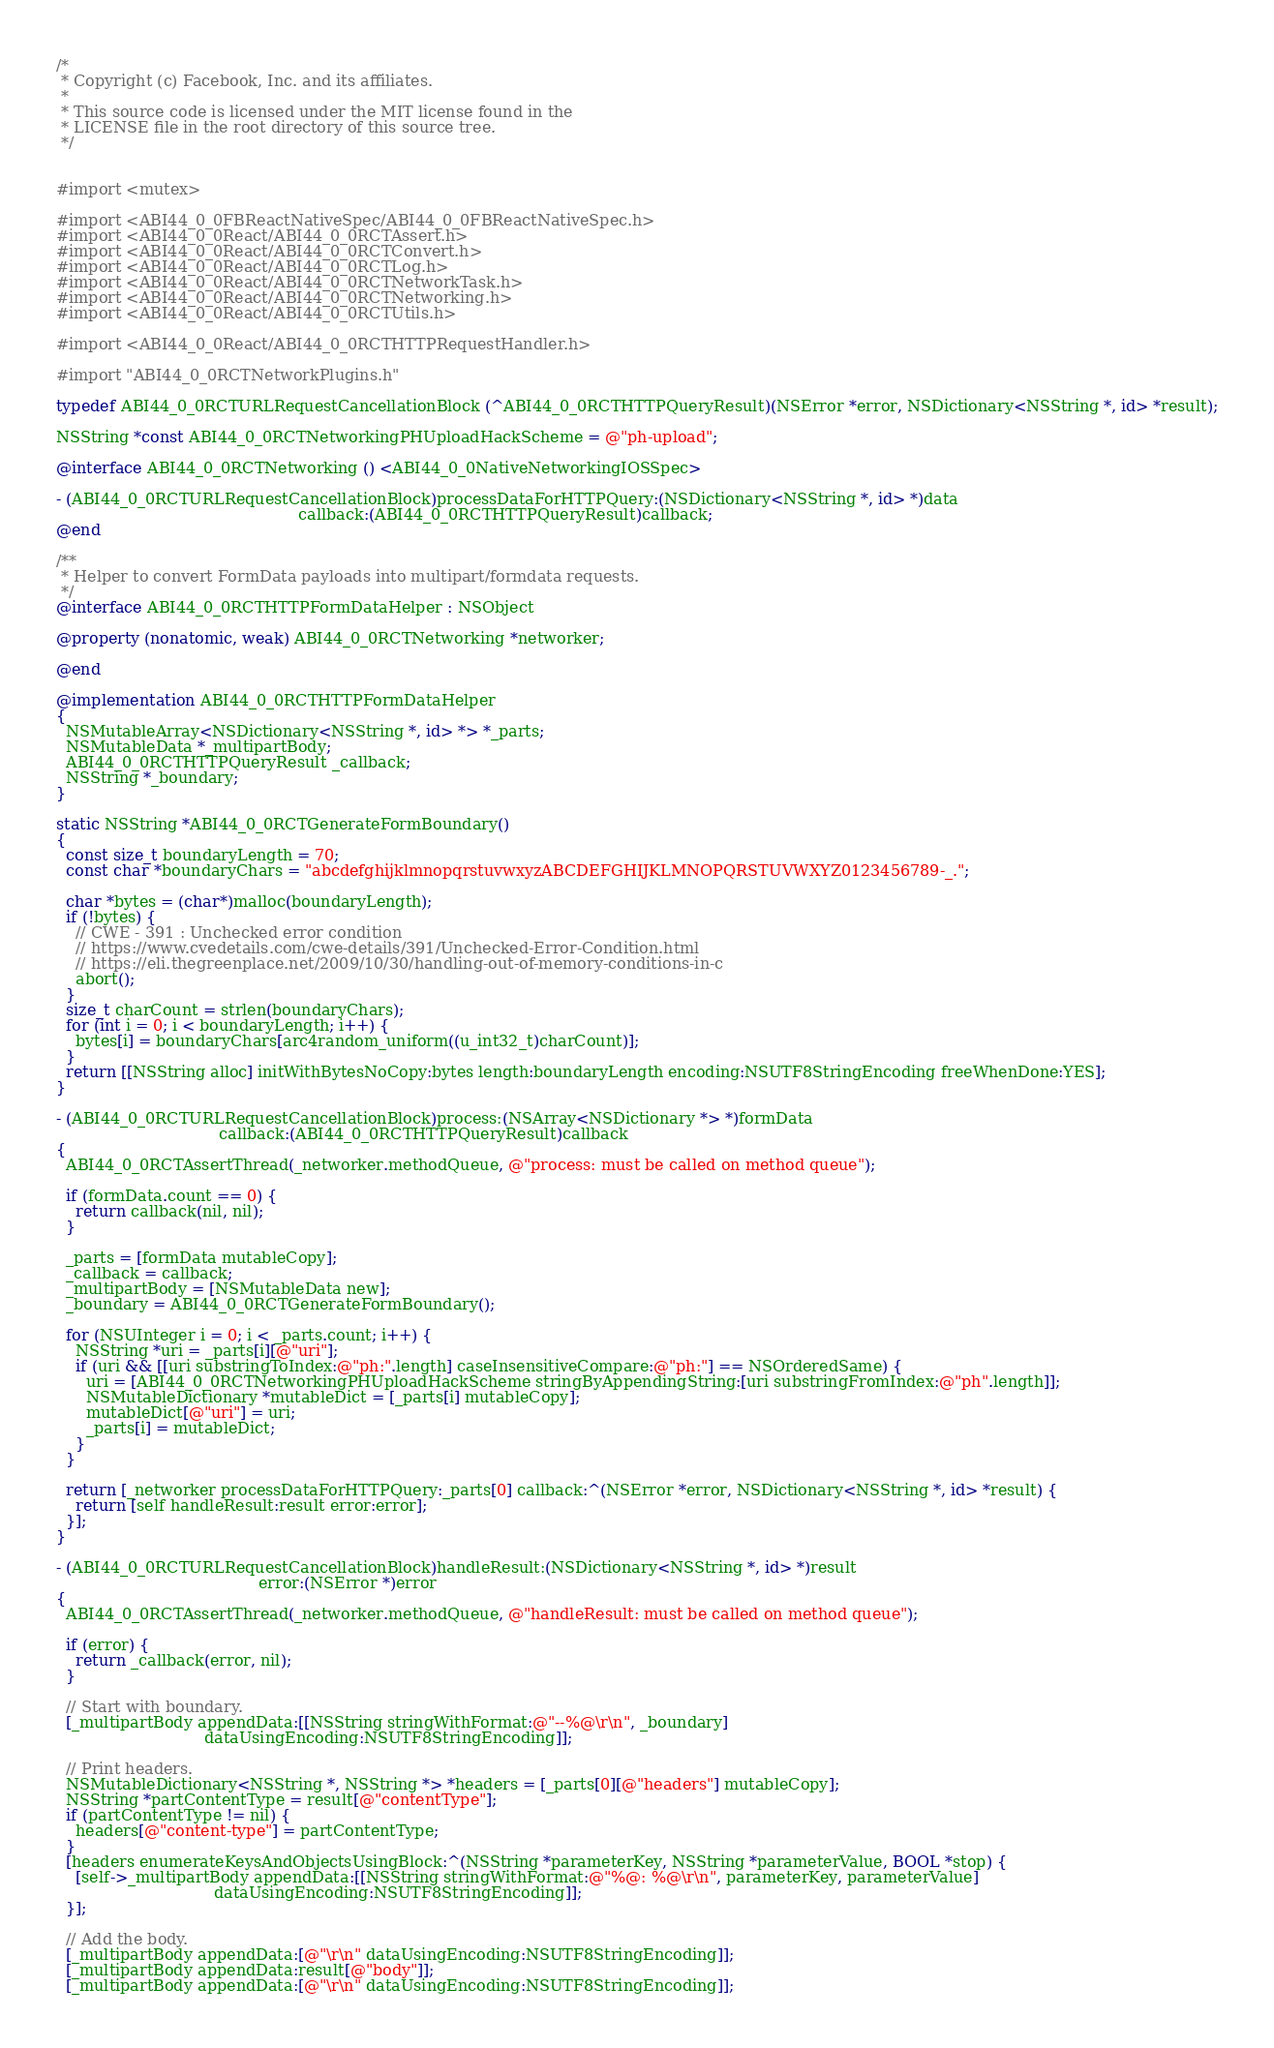Convert code to text. <code><loc_0><loc_0><loc_500><loc_500><_ObjectiveC_>/*
 * Copyright (c) Facebook, Inc. and its affiliates.
 *
 * This source code is licensed under the MIT license found in the
 * LICENSE file in the root directory of this source tree.
 */


#import <mutex>

#import <ABI44_0_0FBReactNativeSpec/ABI44_0_0FBReactNativeSpec.h>
#import <ABI44_0_0React/ABI44_0_0RCTAssert.h>
#import <ABI44_0_0React/ABI44_0_0RCTConvert.h>
#import <ABI44_0_0React/ABI44_0_0RCTLog.h>
#import <ABI44_0_0React/ABI44_0_0RCTNetworkTask.h>
#import <ABI44_0_0React/ABI44_0_0RCTNetworking.h>
#import <ABI44_0_0React/ABI44_0_0RCTUtils.h>

#import <ABI44_0_0React/ABI44_0_0RCTHTTPRequestHandler.h>

#import "ABI44_0_0RCTNetworkPlugins.h"

typedef ABI44_0_0RCTURLRequestCancellationBlock (^ABI44_0_0RCTHTTPQueryResult)(NSError *error, NSDictionary<NSString *, id> *result);

NSString *const ABI44_0_0RCTNetworkingPHUploadHackScheme = @"ph-upload";

@interface ABI44_0_0RCTNetworking () <ABI44_0_0NativeNetworkingIOSSpec>

- (ABI44_0_0RCTURLRequestCancellationBlock)processDataForHTTPQuery:(NSDictionary<NSString *, id> *)data
                                                 callback:(ABI44_0_0RCTHTTPQueryResult)callback;
@end

/**
 * Helper to convert FormData payloads into multipart/formdata requests.
 */
@interface ABI44_0_0RCTHTTPFormDataHelper : NSObject

@property (nonatomic, weak) ABI44_0_0RCTNetworking *networker;

@end

@implementation ABI44_0_0RCTHTTPFormDataHelper
{
  NSMutableArray<NSDictionary<NSString *, id> *> *_parts;
  NSMutableData *_multipartBody;
  ABI44_0_0RCTHTTPQueryResult _callback;
  NSString *_boundary;
}

static NSString *ABI44_0_0RCTGenerateFormBoundary()
{
  const size_t boundaryLength = 70;
  const char *boundaryChars = "abcdefghijklmnopqrstuvwxyzABCDEFGHIJKLMNOPQRSTUVWXYZ0123456789-_.";

  char *bytes = (char*)malloc(boundaryLength);
  if (!bytes) {
    // CWE - 391 : Unchecked error condition
    // https://www.cvedetails.com/cwe-details/391/Unchecked-Error-Condition.html
    // https://eli.thegreenplace.net/2009/10/30/handling-out-of-memory-conditions-in-c
    abort();
  }
  size_t charCount = strlen(boundaryChars);
  for (int i = 0; i < boundaryLength; i++) {
    bytes[i] = boundaryChars[arc4random_uniform((u_int32_t)charCount)];
  }
  return [[NSString alloc] initWithBytesNoCopy:bytes length:boundaryLength encoding:NSUTF8StringEncoding freeWhenDone:YES];
}

- (ABI44_0_0RCTURLRequestCancellationBlock)process:(NSArray<NSDictionary *> *)formData
                                 callback:(ABI44_0_0RCTHTTPQueryResult)callback
{
  ABI44_0_0RCTAssertThread(_networker.methodQueue, @"process: must be called on method queue");

  if (formData.count == 0) {
    return callback(nil, nil);
  }

  _parts = [formData mutableCopy];
  _callback = callback;
  _multipartBody = [NSMutableData new];
  _boundary = ABI44_0_0RCTGenerateFormBoundary();

  for (NSUInteger i = 0; i < _parts.count; i++) {
    NSString *uri = _parts[i][@"uri"];
    if (uri && [[uri substringToIndex:@"ph:".length] caseInsensitiveCompare:@"ph:"] == NSOrderedSame) {
      uri = [ABI44_0_0RCTNetworkingPHUploadHackScheme stringByAppendingString:[uri substringFromIndex:@"ph".length]];
      NSMutableDictionary *mutableDict = [_parts[i] mutableCopy];
      mutableDict[@"uri"] = uri;
      _parts[i] = mutableDict;
    }
  }

  return [_networker processDataForHTTPQuery:_parts[0] callback:^(NSError *error, NSDictionary<NSString *, id> *result) {
    return [self handleResult:result error:error];
  }];
}

- (ABI44_0_0RCTURLRequestCancellationBlock)handleResult:(NSDictionary<NSString *, id> *)result
                                         error:(NSError *)error
{
  ABI44_0_0RCTAssertThread(_networker.methodQueue, @"handleResult: must be called on method queue");

  if (error) {
    return _callback(error, nil);
  }

  // Start with boundary.
  [_multipartBody appendData:[[NSString stringWithFormat:@"--%@\r\n", _boundary]
                              dataUsingEncoding:NSUTF8StringEncoding]];

  // Print headers.
  NSMutableDictionary<NSString *, NSString *> *headers = [_parts[0][@"headers"] mutableCopy];
  NSString *partContentType = result[@"contentType"];
  if (partContentType != nil) {
    headers[@"content-type"] = partContentType;
  }
  [headers enumerateKeysAndObjectsUsingBlock:^(NSString *parameterKey, NSString *parameterValue, BOOL *stop) {
    [self->_multipartBody appendData:[[NSString stringWithFormat:@"%@: %@\r\n", parameterKey, parameterValue]
                                dataUsingEncoding:NSUTF8StringEncoding]];
  }];

  // Add the body.
  [_multipartBody appendData:[@"\r\n" dataUsingEncoding:NSUTF8StringEncoding]];
  [_multipartBody appendData:result[@"body"]];
  [_multipartBody appendData:[@"\r\n" dataUsingEncoding:NSUTF8StringEncoding]];
</code> 